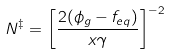Convert formula to latex. <formula><loc_0><loc_0><loc_500><loc_500>N ^ { \ddagger } = \left [ \frac { 2 ( \phi _ { g } - f _ { e q } ) } { x \gamma } \right ] ^ { - 2 }</formula> 